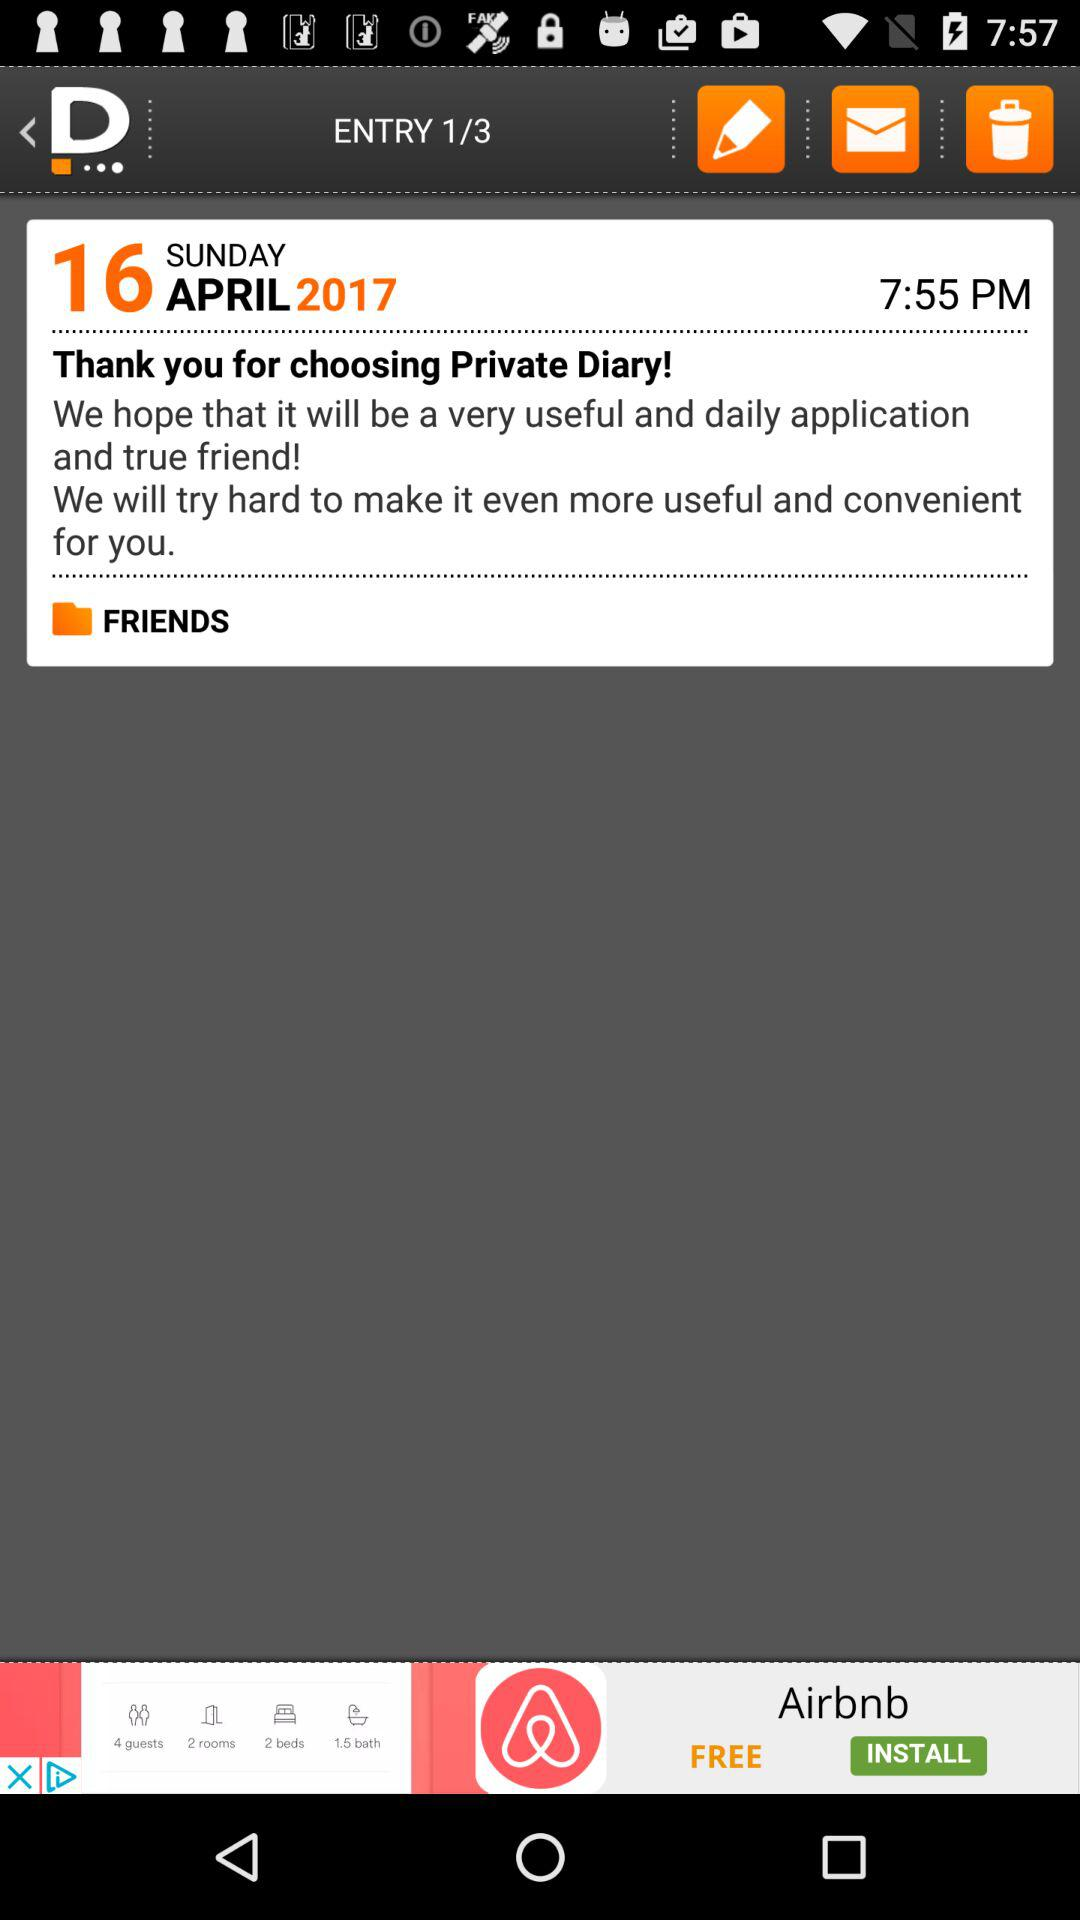How many entries are there? There are 3 entries. 